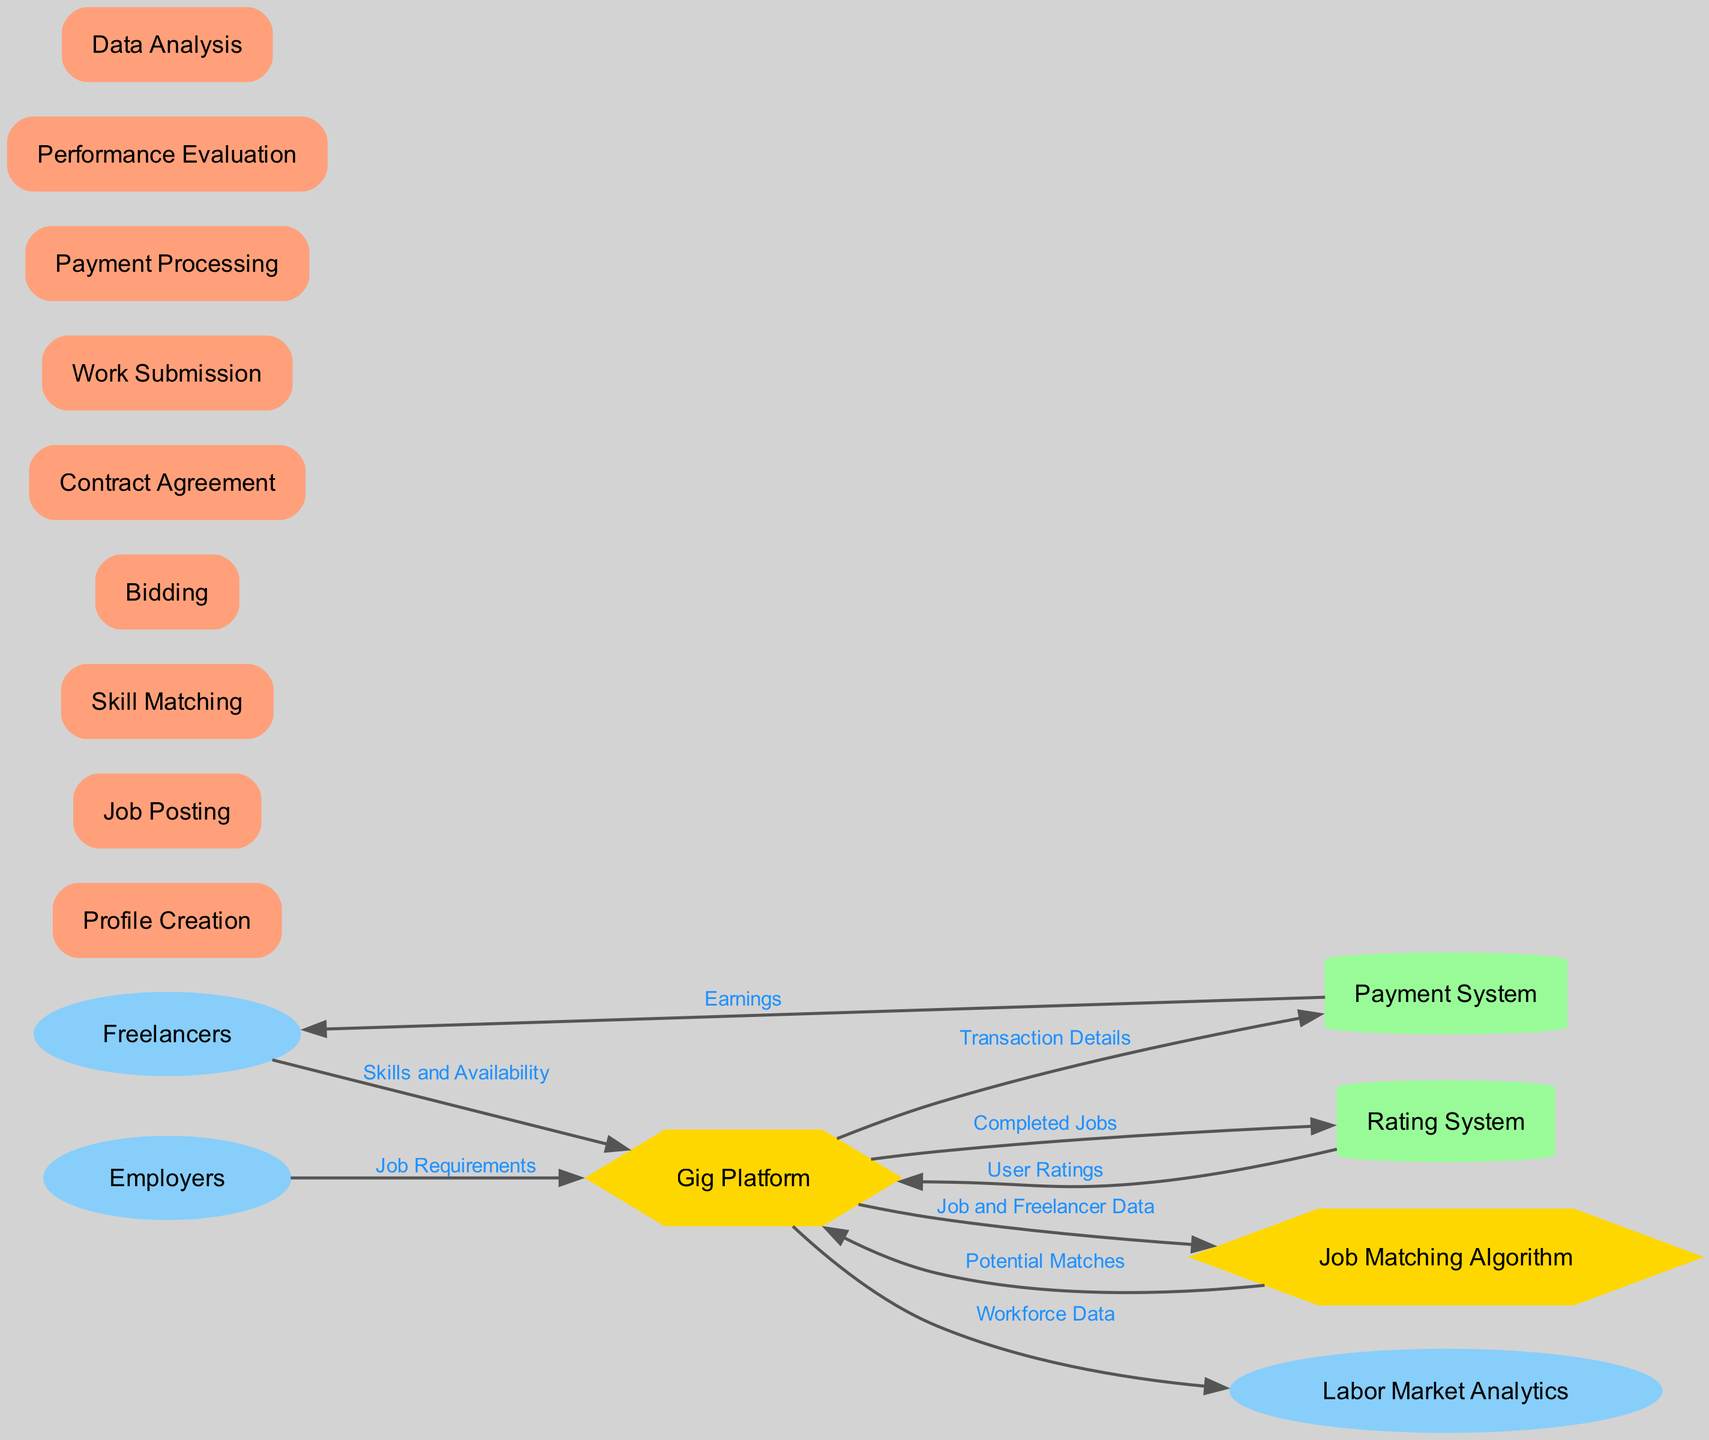What entities interact with the Gig Platform? The Gig Platform interacts with six entities: Freelancers, Employers, Payment System, Rating System, Job Matching Algorithm, and Labor Market Analytics. These interactions are visually represented as direct connections to the Gig Platform.
Answer: Freelancers, Employers, Payment System, Rating System, Job Matching Algorithm, Labor Market Analytics How many data flows are represented in the diagram? The diagram includes eight distinct data flows, each connecting two nodes and labeled with the type of information being exchanged.
Answer: Eight What information do Freelancers send to the Gig Platform? Freelancers provide their Skills and Availability to the Gig Platform, as indicated by the data flow labeled "Skills and Availability."
Answer: Skills and Availability From which entity does the Rating System receive its data? The Rating System receives its data from the Gig Platform, specifically through completed jobs that are represented in the data flow labeled "Completed Jobs."
Answer: Gig Platform What process occurs after Job Posting? After Job Posting, the next process is Skill Matching. This is the sequence of processes linked together in the flow of the diagram.
Answer: Skill Matching How does the Gig Platform utilize the Job Matching Algorithm? The Gig Platform sends Job and Freelancer Data to the Job Matching Algorithm, which then returns Potential Matches to the Gig Platform. This back-and-forth exchange illustrates the role of the Job Matching Algorithm in identifying suitable freelancers for posted jobs.
Answer: Job and Freelancer Data What does the Payment System deliver to Freelancers? The Payment System processes transactions and delivers Earnings to Freelancers, as indicated in the diagram by the labeled data flow "Earnings."
Answer: Earnings Which process follows Work Submission? Following Work Submission, the Performance Evaluation process takes place, indicating that evaluations of the freelancer's work are conducted after the work is submitted.
Answer: Performance Evaluation 